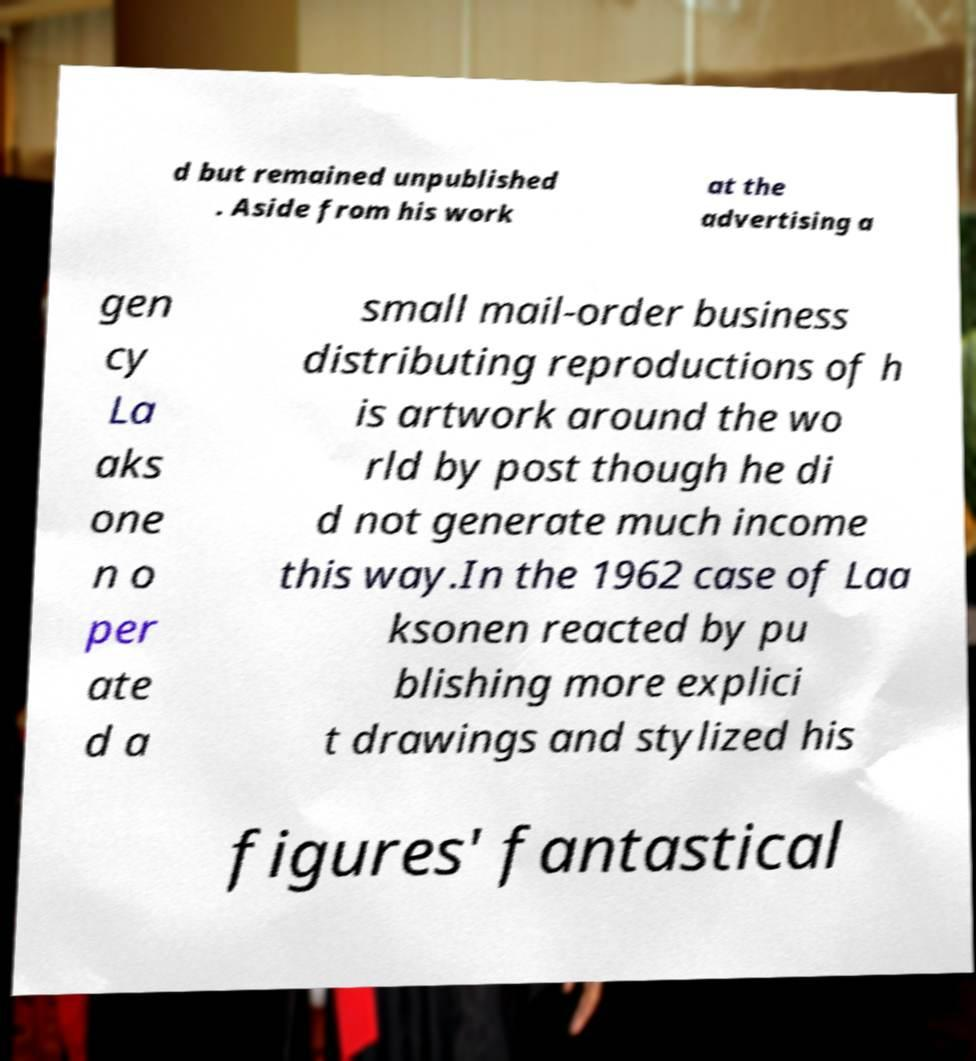For documentation purposes, I need the text within this image transcribed. Could you provide that? d but remained unpublished . Aside from his work at the advertising a gen cy La aks one n o per ate d a small mail-order business distributing reproductions of h is artwork around the wo rld by post though he di d not generate much income this way.In the 1962 case of Laa ksonen reacted by pu blishing more explici t drawings and stylized his figures' fantastical 